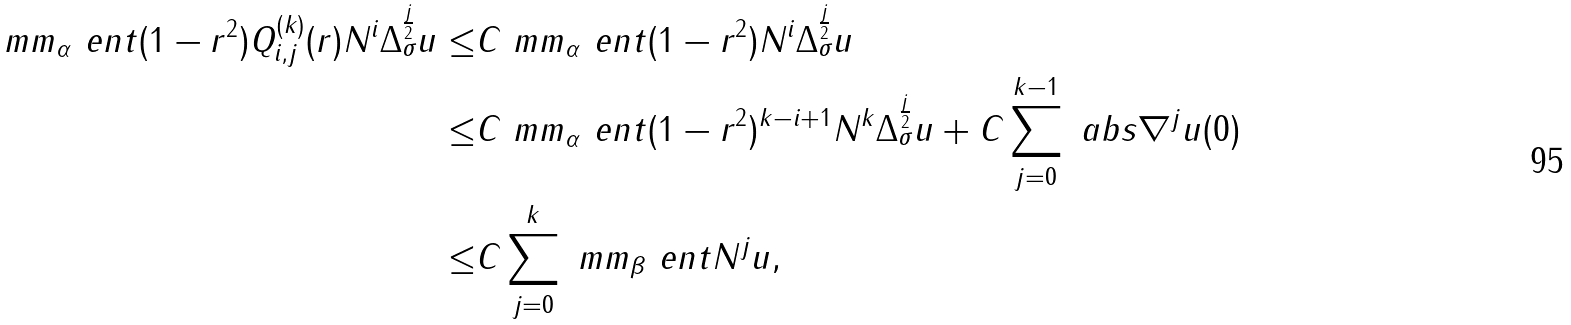<formula> <loc_0><loc_0><loc_500><loc_500>\ m m _ { \alpha } \ e n t { ( 1 - r ^ { 2 } ) Q _ { i , j } ^ { ( k ) } ( r ) N ^ { i } \Delta _ { \sigma } ^ { \frac { j } { 2 } } u } \leq & C \ m m _ { \alpha } \ e n t { ( 1 - r ^ { 2 } ) N ^ { i } \Delta _ { \sigma } ^ { \frac { j } { 2 } } u } \\ \leq & C \ m m _ { \alpha } \ e n t { ( 1 - r ^ { 2 } ) ^ { k - i + 1 } N ^ { k } \Delta _ { \sigma } ^ { \frac { j } { 2 } } u } + C \sum _ { j = 0 } ^ { k - 1 } \ a b s { \nabla ^ { j } u ( 0 ) } \\ \leq & C \sum _ { j = 0 } ^ { k } \ m m _ { \beta } \ e n t { N ^ { j } u } ,</formula> 